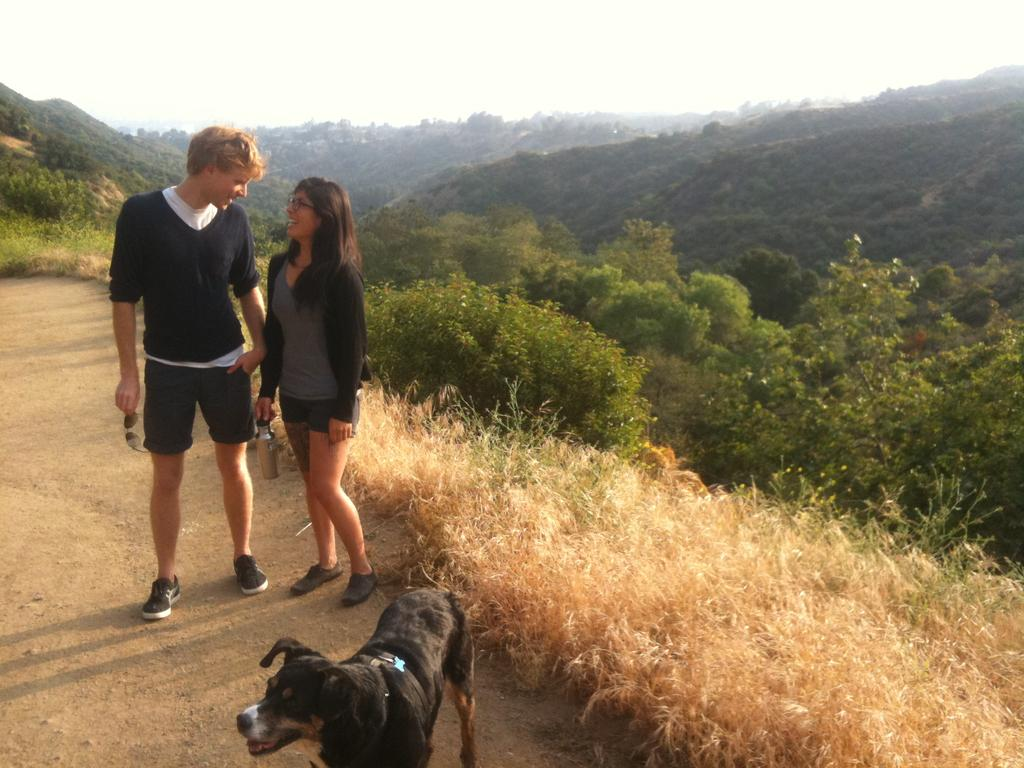How many people are present in the image? There is a man and a woman present in the image. What other living creature is in the image? There is a dog in the image. Where are the man, woman, and dog located? They are standing on the ground in the image. What can be seen in the background of the image? Hills, trees, grass, bushes, and the sky are visible in the background of the image. What type of education does the man have in the image? There is no information about the man's education in the image. Can you tell me how many frogs are present in the image? There are no frogs present in the image. 